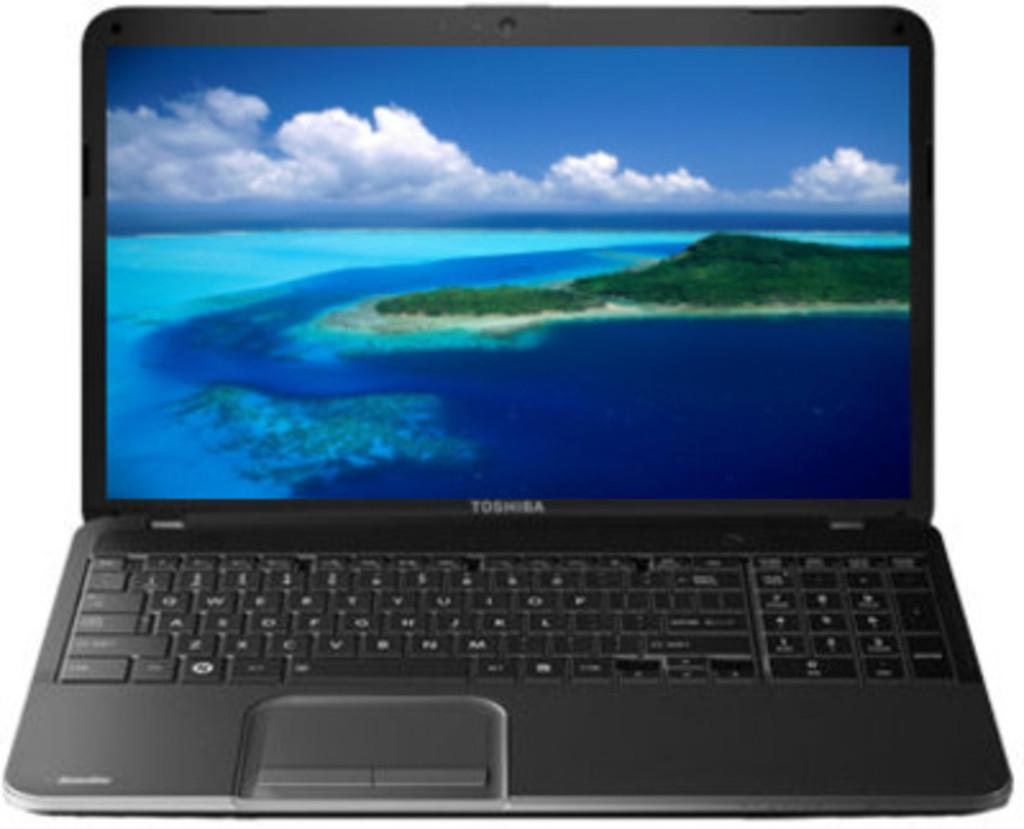What electronic device is visible in the image? There is a laptop in the image. What is displayed on the laptop screen? The laptop screen displays a water surface, trees, and clouds in the sky. What language does the dad speak in the image? There is no dad present in the image, and therefore no language can be attributed to him. 